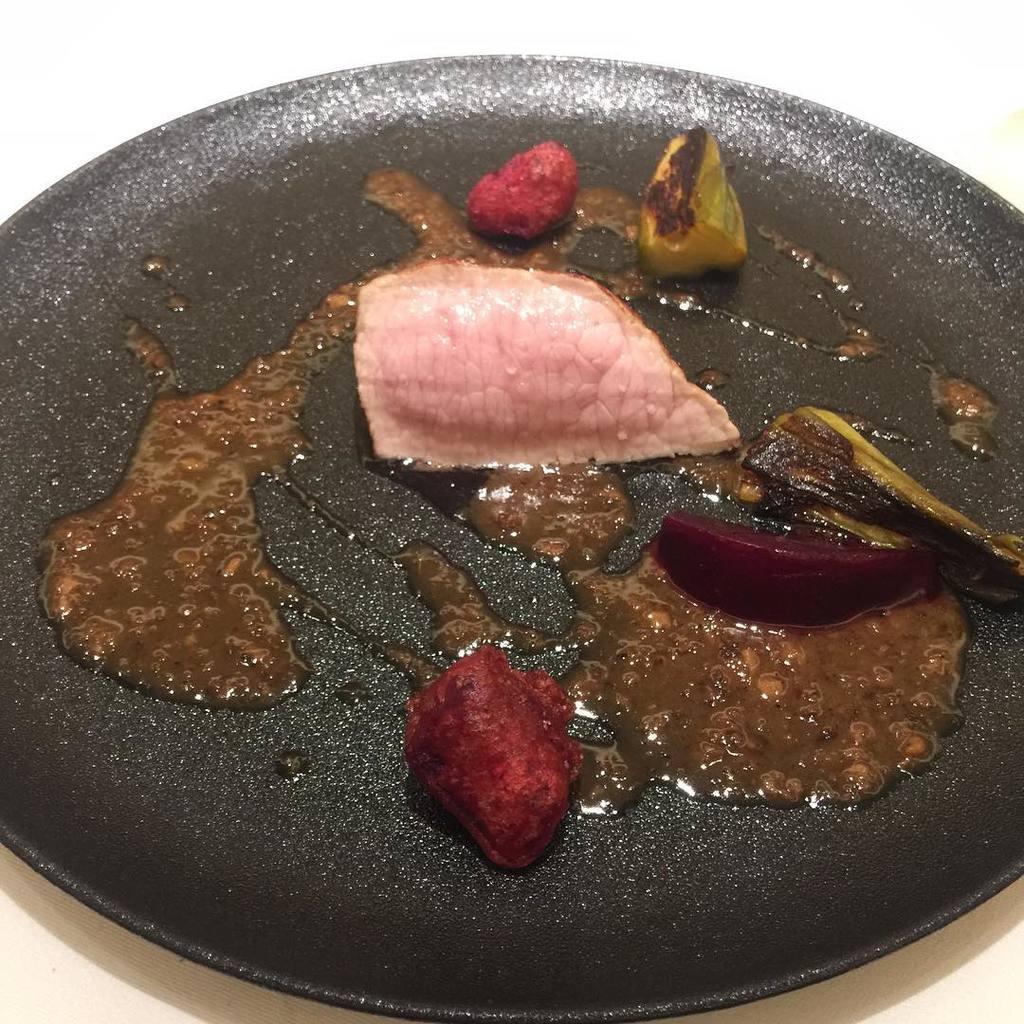Please provide a concise description of this image. In this image I can see a black colored pan on the white colored surface and in the pan I can see a brown colored liquid and few food items which are pink, red, green, black and maroon in color. 